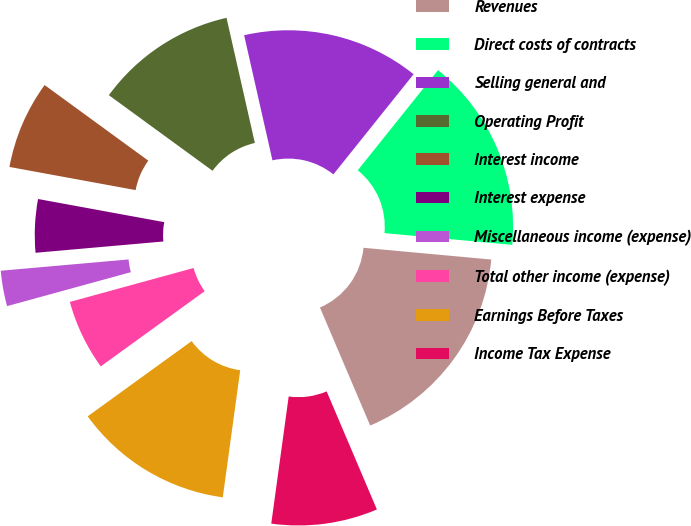Convert chart to OTSL. <chart><loc_0><loc_0><loc_500><loc_500><pie_chart><fcel>Revenues<fcel>Direct costs of contracts<fcel>Selling general and<fcel>Operating Profit<fcel>Interest income<fcel>Interest expense<fcel>Miscellaneous income (expense)<fcel>Total other income (expense)<fcel>Earnings Before Taxes<fcel>Income Tax Expense<nl><fcel>17.14%<fcel>15.71%<fcel>14.29%<fcel>11.43%<fcel>7.14%<fcel>4.29%<fcel>2.86%<fcel>5.71%<fcel>12.86%<fcel>8.57%<nl></chart> 